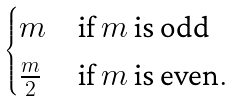<formula> <loc_0><loc_0><loc_500><loc_500>\begin{cases} m & { \text {if $m$ is odd} } \\ \frac { m } { 2 } & { \text {if $m$ is even} . } \end{cases}</formula> 